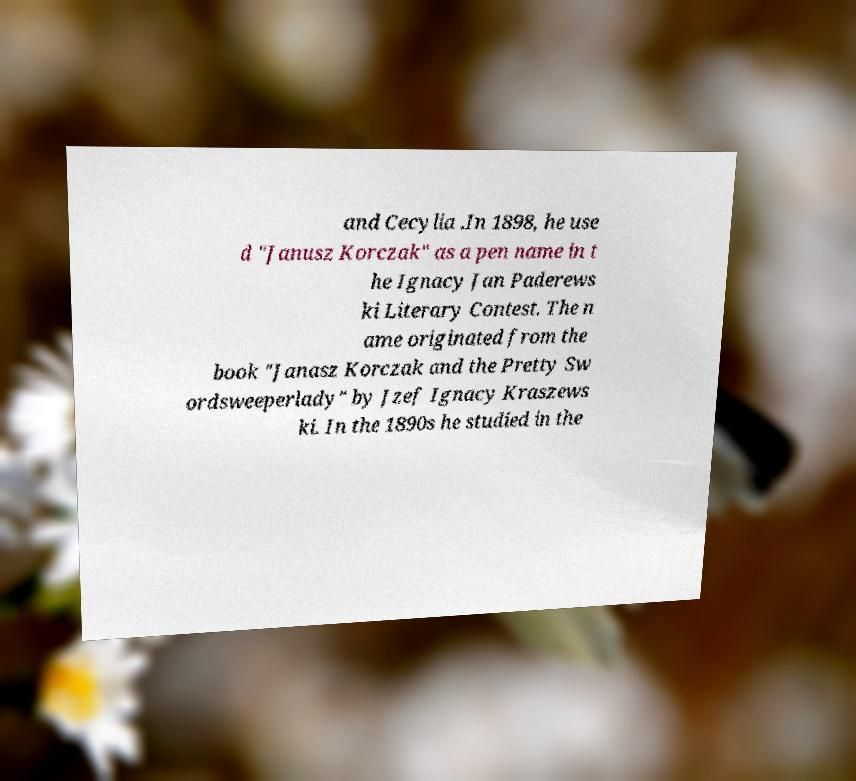Can you accurately transcribe the text from the provided image for me? and Cecylia .In 1898, he use d "Janusz Korczak" as a pen name in t he Ignacy Jan Paderews ki Literary Contest. The n ame originated from the book "Janasz Korczak and the Pretty Sw ordsweeperlady" by Jzef Ignacy Kraszews ki. In the 1890s he studied in the 